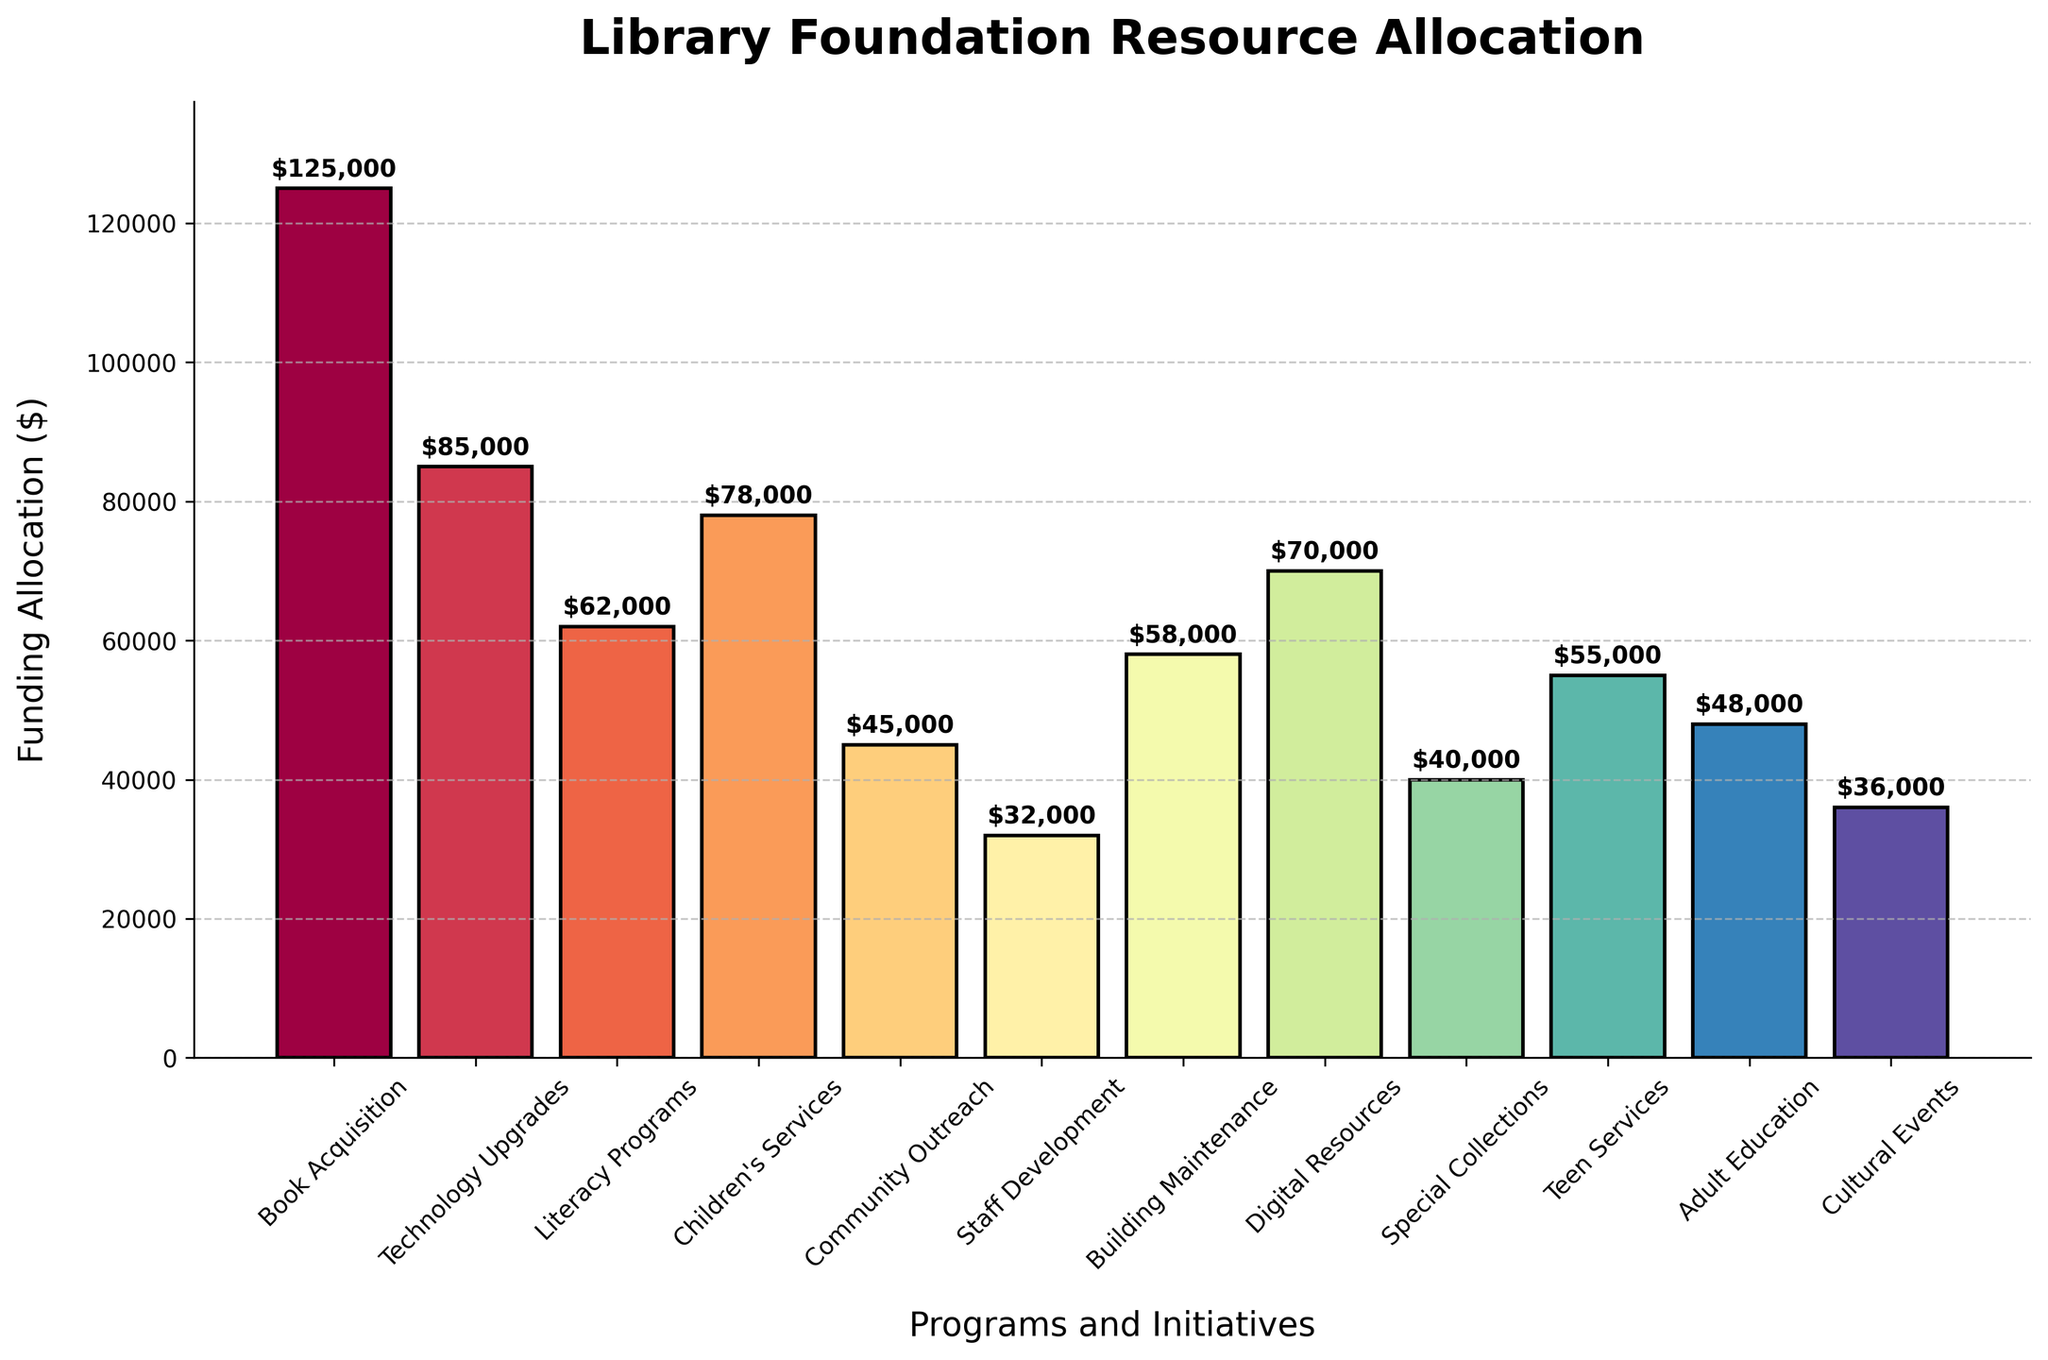What is the program with the highest funding allocation? The figure shows various programs along the x-axis with their corresponding funding allocations on the y-axis. The tallest bar represents the program with the highest allocation.
Answer: Book Acquisition How much more funding does Technology Upgrades receive compared to Teen Services? To find this difference, refer to the heights of the bars for Technology Upgrades and Teen Services. Subtract the allocation for Teen Services from that for Technology Upgrades: $85,000 - $55,000.
Answer: $30,000 Which programs received less funding than Children's Services? Identify the bar for Children's Services, which has a funding of $78,000. Any program with a bar shorter than this represents programs with less funding.
Answer: Literacy Programs, Community Outreach, Staff Development, Building Maintenance, Digital Resources, Special Collections, Teen Services, Adult Education, Cultural Events What is the total funding allocated to Literacy Programs, Community Outreach, and Special Collections? Add the funding allocations for these programs: $62,000 (Literacy Programs) + $45,000 (Community Outreach) + $40,000 (Special Collections).
Answer: $147,000 Which program has the closest funding allocation to $50,000? Look at the bars representing different programs and find the one whose height is closest to $50,000.
Answer: Teen Services Is the funding for Digital Resources greater than that for Building Maintenance? Compare the bars for Digital Resources and Building Maintenance. Digital Resources has a bar taller than Building Maintenance.
Answer: Yes What is the average funding allocation for Children's Services, Digital Resources, and Adult Education? Add the funding allocations for these programs and then divide by three: ($78,000 + $70,000 + $48,000) / 3.
Answer: $65,333 Which program received the second highest funding? Identify the program with the second tallest bar after the tallest bar (Book Acquisition).
Answer: Technology Upgrades How much is the difference between the highest and the lowest funding allocations? The highest allocation is for Book Acquisition at $125,000, and the lowest is for Staff Development at $32,000. Subtract the lowest from the highest: $125,000 - $32,000.
Answer: $93,000 